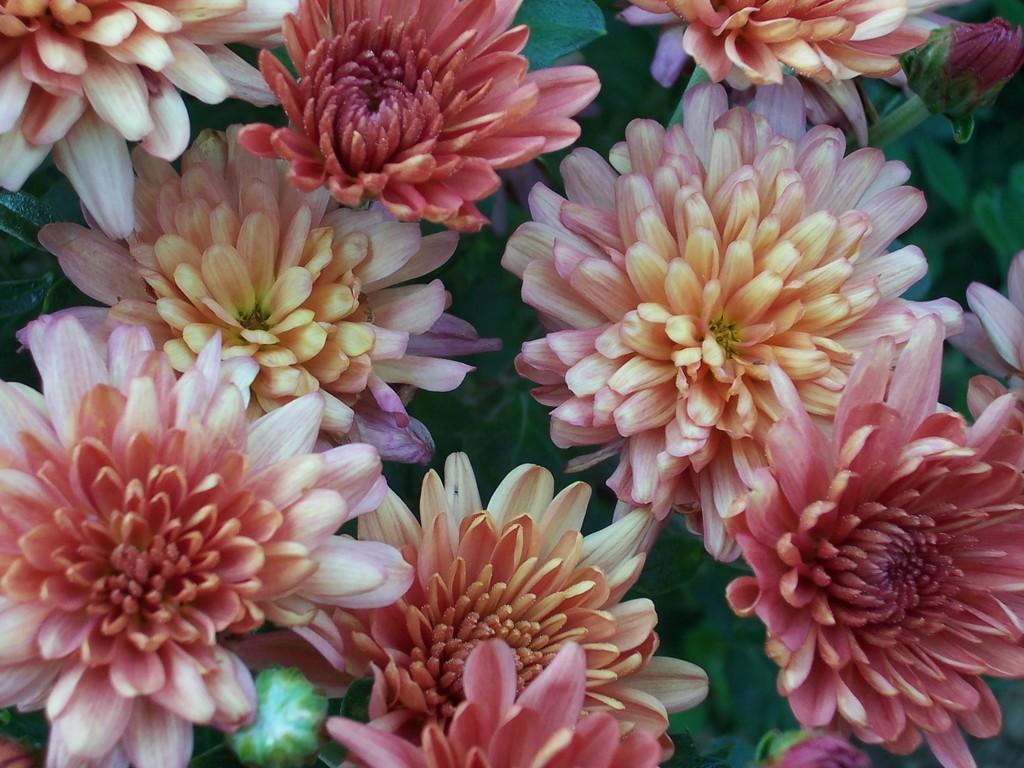Describe this image in one or two sentences. In this picture I can see flowers and few leaves. 